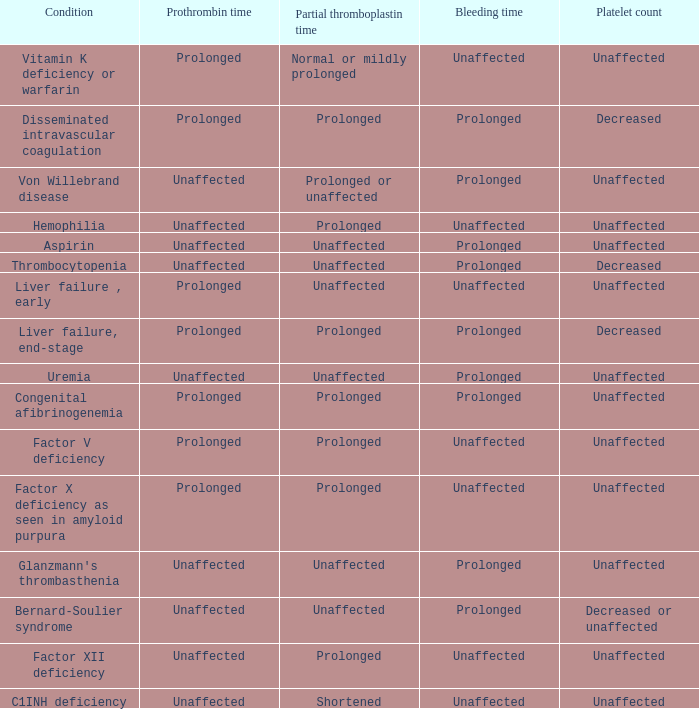What is hemophilia's bleeding time? Unaffected. 